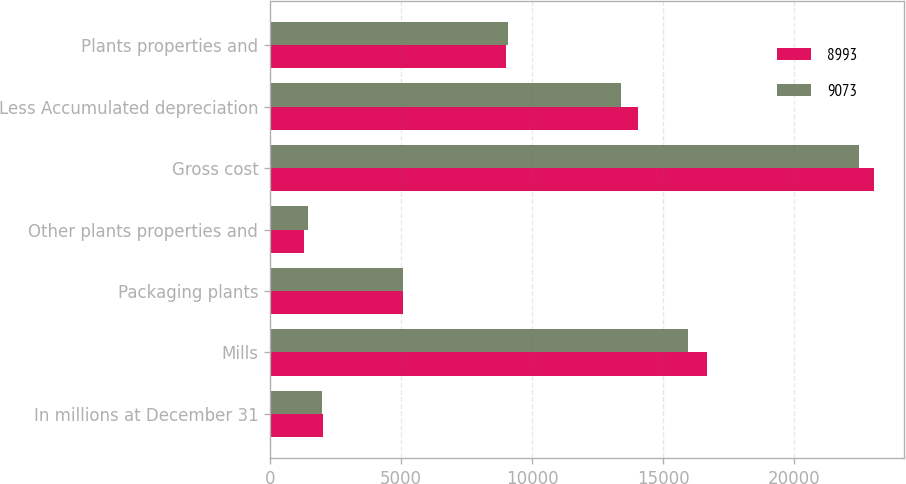Convert chart to OTSL. <chart><loc_0><loc_0><loc_500><loc_500><stacked_bar_chart><ecel><fcel>In millions at December 31<fcel>Mills<fcel>Packaging plants<fcel>Other plants properties and<fcel>Gross cost<fcel>Less Accumulated depreciation<fcel>Plants properties and<nl><fcel>8993<fcel>2006<fcel>16665<fcel>5093<fcel>1285<fcel>23043<fcel>14050<fcel>8993<nl><fcel>9073<fcel>2005<fcel>15968<fcel>5068<fcel>1450<fcel>22486<fcel>13413<fcel>9073<nl></chart> 